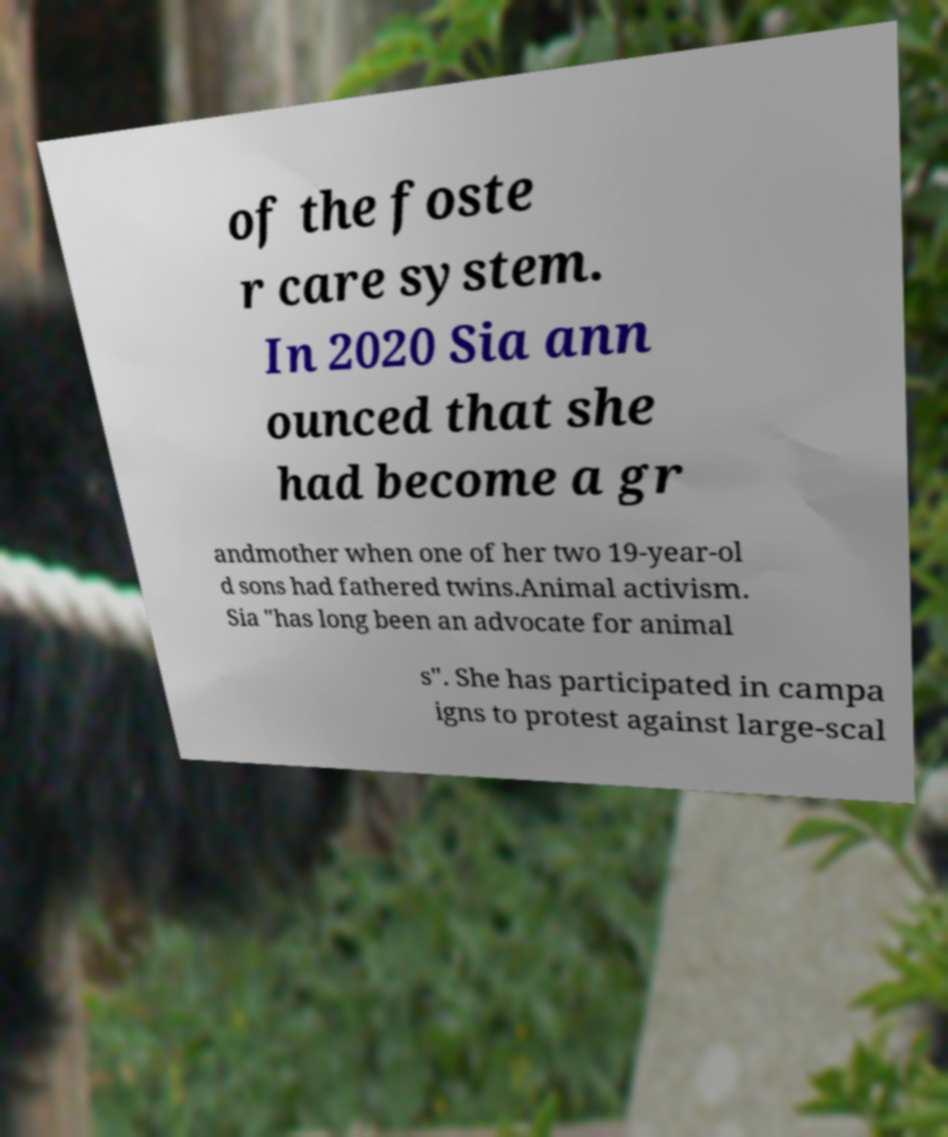For documentation purposes, I need the text within this image transcribed. Could you provide that? of the foste r care system. In 2020 Sia ann ounced that she had become a gr andmother when one of her two 19-year-ol d sons had fathered twins.Animal activism. Sia "has long been an advocate for animal s". She has participated in campa igns to protest against large-scal 